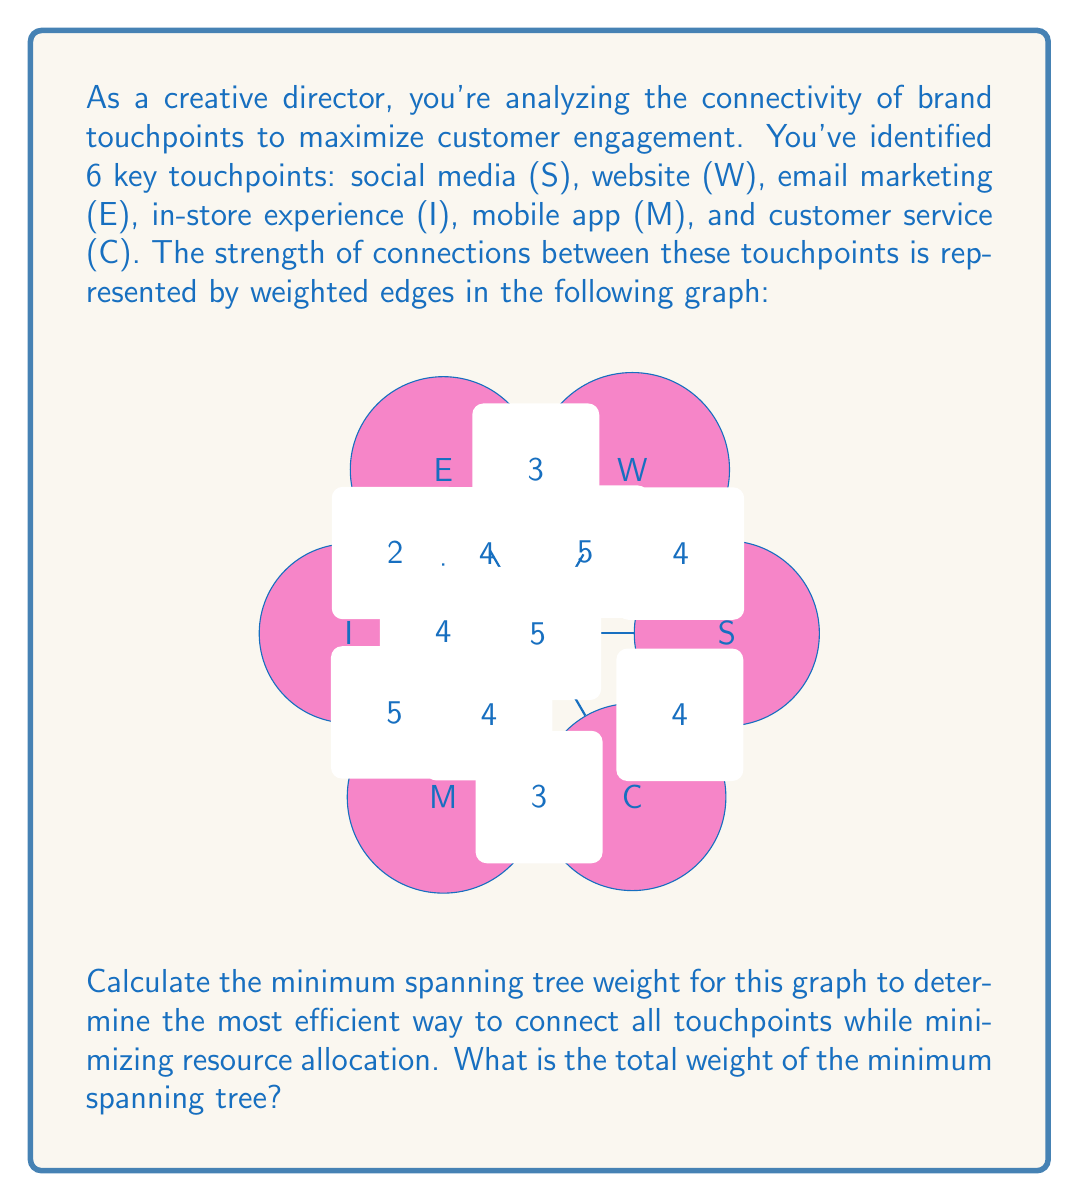Help me with this question. To solve this problem, we'll use Kruskal's algorithm to find the minimum spanning tree (MST) of the given graph. Here are the steps:

1) List all edges in ascending order of weight:
   2: E-I
   3: W-E, M-C, S-I, W-M
   4: S-W, C-S, I-C, W-I, E-M
   5: S-E, D-M, E-C

2) Start with an empty MST and add edges in this order, skipping any that would create a cycle:

   - Add E-I (2)
   - Add W-E (3)
   - Add M-C (3)
   - Skip S-I (would create cycle)
   - Skip W-M (would create cycle)
   - Add S-W (4)
   - Skip C-S (would create cycle)
   - Skip I-C (would create cycle)
   - Skip W-I (would create cycle)
   - Skip E-M (would create cycle)

3) We stop here because we've added 5 edges, which is sufficient to connect all 6 vertices (n-1 edges, where n is the number of vertices).

4) Sum the weights of the selected edges:
   $$2 + 3 + 3 + 4 = 12$$

Therefore, the total weight of the minimum spanning tree is 12.
Answer: 12 